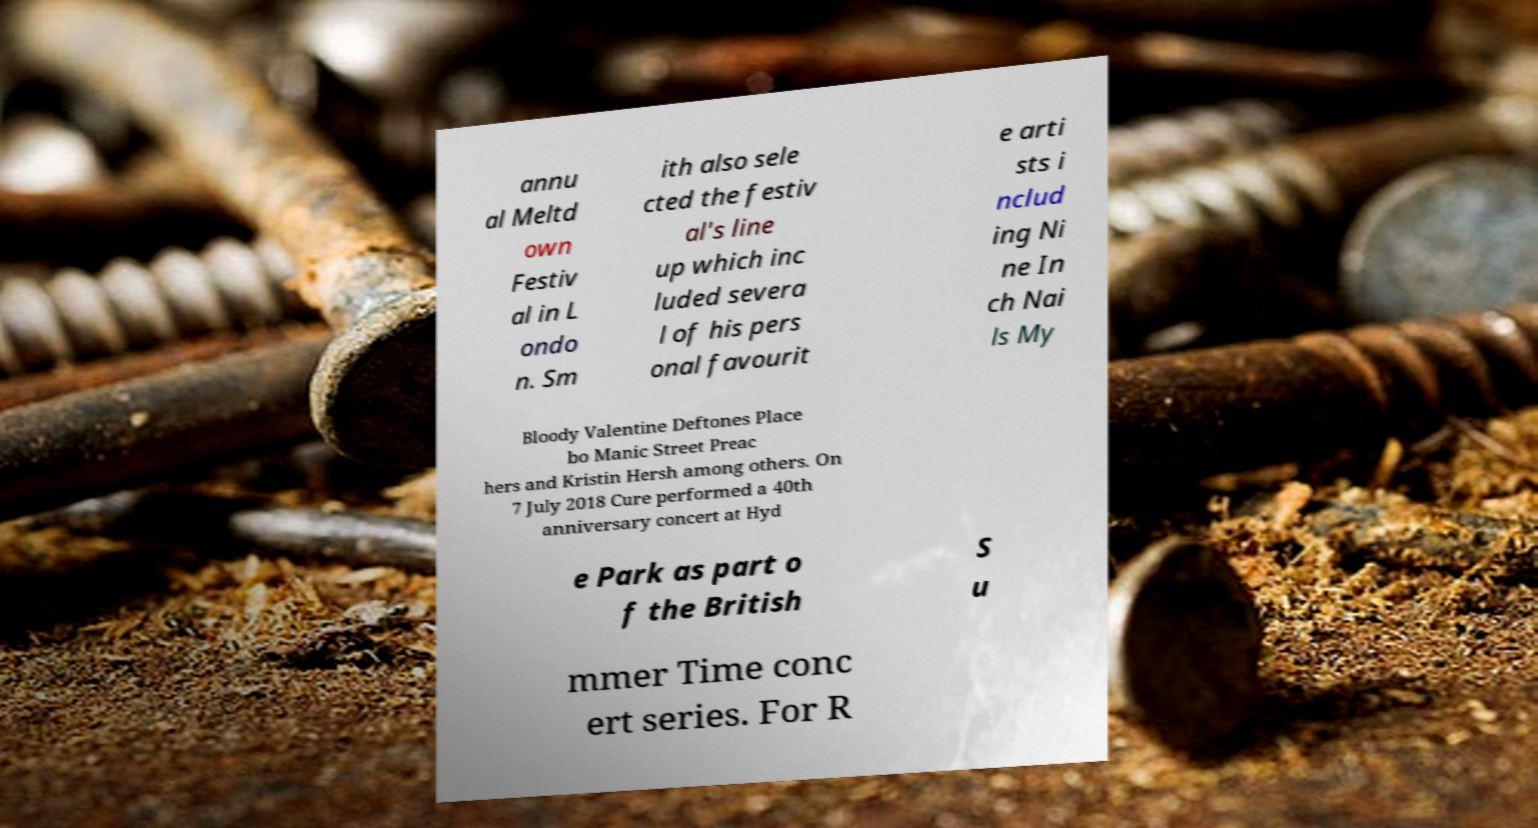Could you assist in decoding the text presented in this image and type it out clearly? annu al Meltd own Festiv al in L ondo n. Sm ith also sele cted the festiv al's line up which inc luded severa l of his pers onal favourit e arti sts i nclud ing Ni ne In ch Nai ls My Bloody Valentine Deftones Place bo Manic Street Preac hers and Kristin Hersh among others. On 7 July 2018 Cure performed a 40th anniversary concert at Hyd e Park as part o f the British S u mmer Time conc ert series. For R 